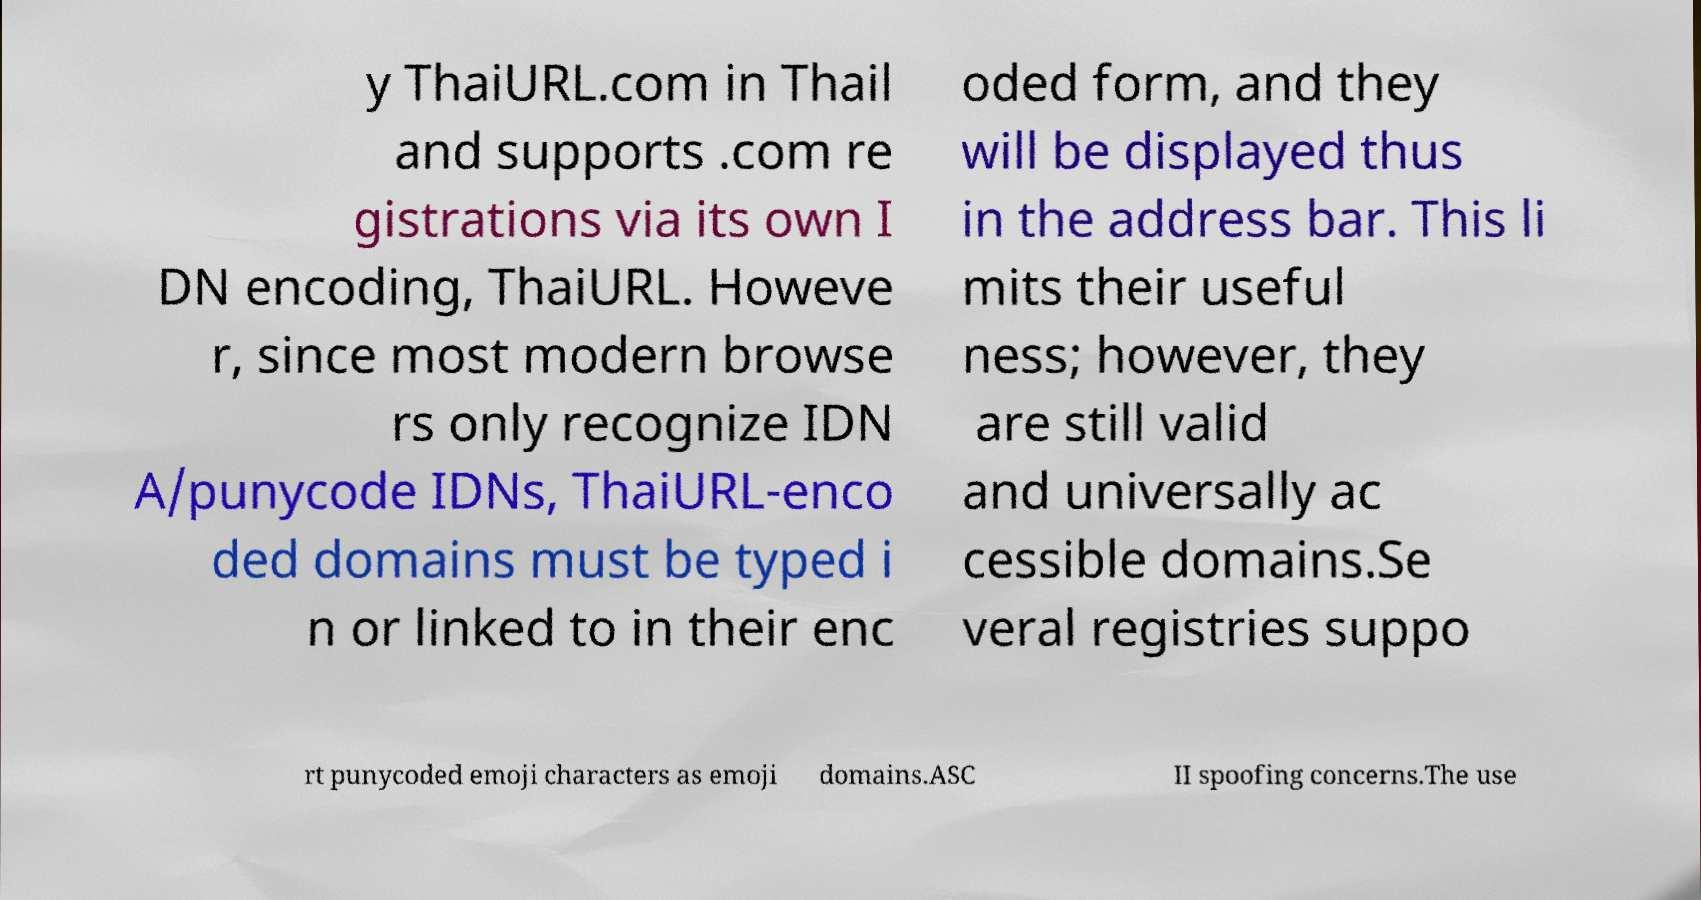What messages or text are displayed in this image? I need them in a readable, typed format. y ThaiURL.com in Thail and supports .com re gistrations via its own I DN encoding, ThaiURL. Howeve r, since most modern browse rs only recognize IDN A/punycode IDNs, ThaiURL-enco ded domains must be typed i n or linked to in their enc oded form, and they will be displayed thus in the address bar. This li mits their useful ness; however, they are still valid and universally ac cessible domains.Se veral registries suppo rt punycoded emoji characters as emoji domains.ASC II spoofing concerns.The use 